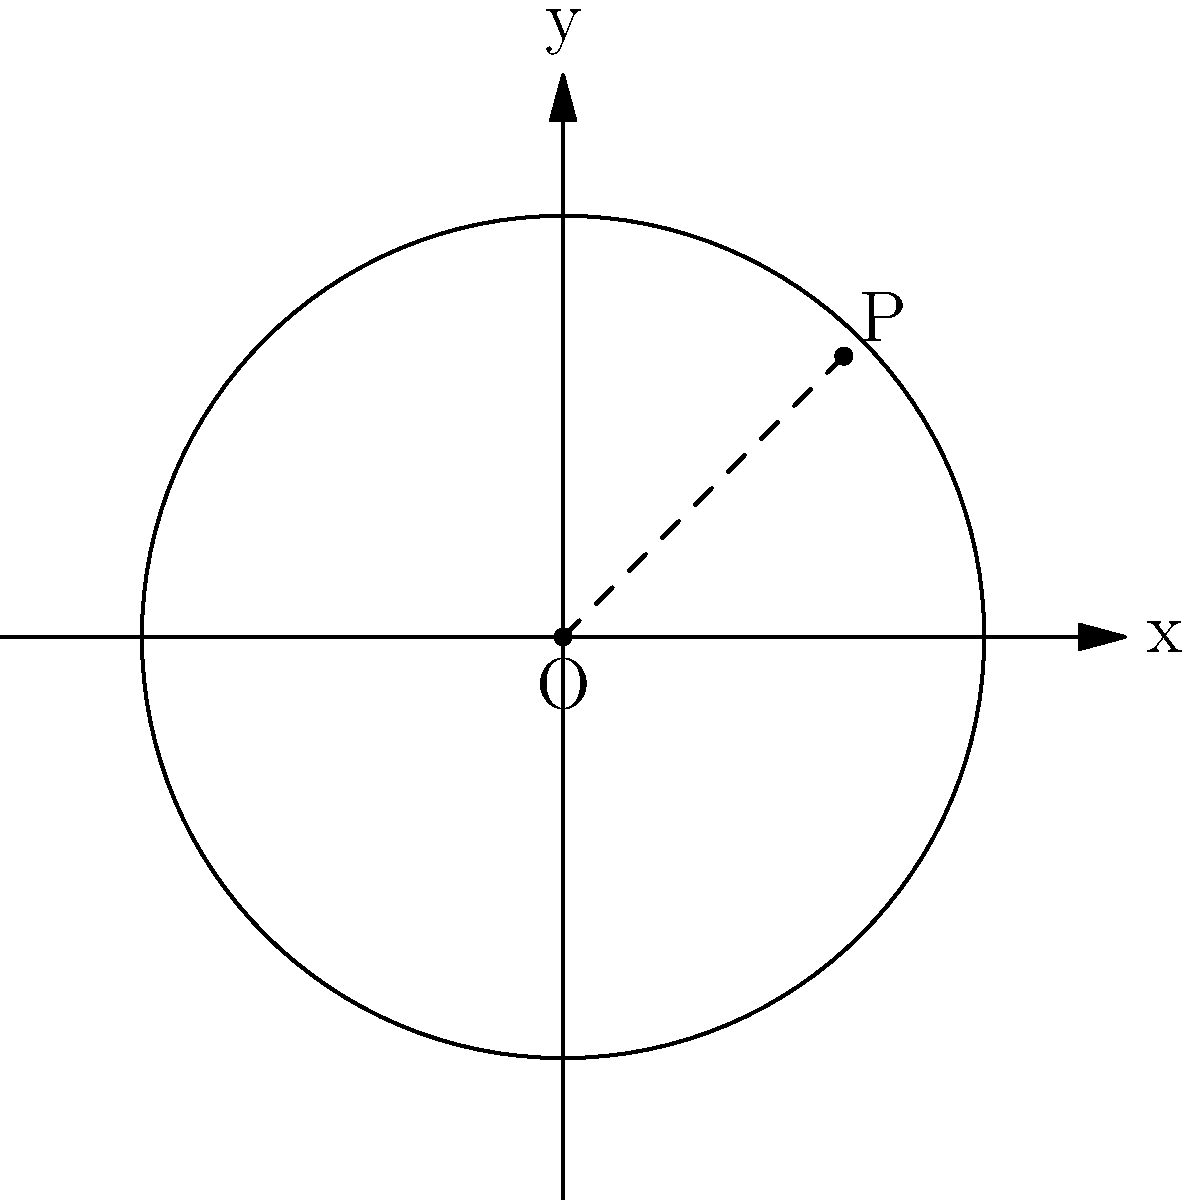Your son's metal band is planning a concert in an arena, and you're helping with the sound system setup. The sound system's reach can be represented by a circle in the arena. If the center of the arena is at the origin (0,0) and the sound reaches a point P(2,2), what is the equation of the circle representing the sound system's reach? Let's approach this step-by-step:

1) The general equation of a circle is $$(x-h)^2 + (y-k)^2 = r^2$$
   where (h,k) is the center and r is the radius.

2) We're given that the center is at the origin (0,0), so h=0 and k=0.
   Our equation simplifies to $$x^2 + y^2 = r^2$$

3) To find r, we can use the point P(2,2) that lies on the circle.
   Substituting these coordinates into our equation:

   $$2^2 + 2^2 = r^2$$

4) Simplify:
   $$4 + 4 = r^2$$
   $$8 = r^2$$

5) Take the square root of both sides:
   $$r = \sqrt{8} = 2\sqrt{2}$$

6) Now we can write our final equation by substituting $r^2 = 8$:

   $$x^2 + y^2 = 8$$
Answer: $x^2 + y^2 = 8$ 